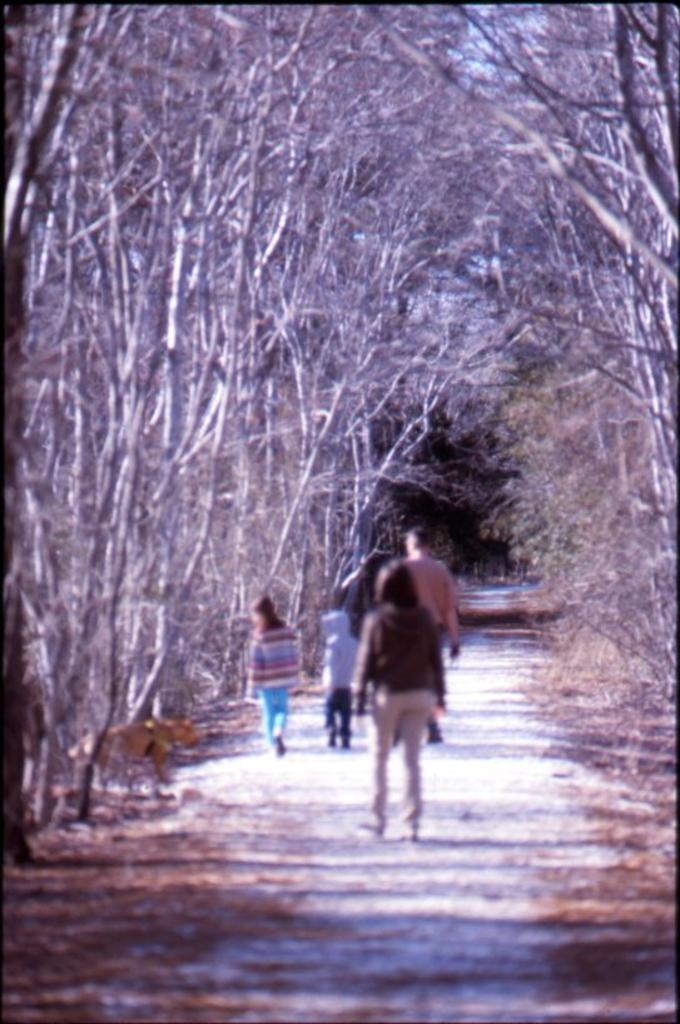How many people are in the image? There is a group of people in the image, but the exact number cannot be determined from the provided facts. Where are the people located in the image? The people are standing on a pathway in the image. What can be seen in the background of the image? There is a group of trees in the image. What note is being played by the silver instrument in the image? There is no silver instrument present in the image, so it is not possible to determine what note might be played. 